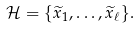Convert formula to latex. <formula><loc_0><loc_0><loc_500><loc_500>\mathcal { H } = \{ \widetilde { x } _ { 1 } , \dots , \widetilde { x } _ { \ell } \} .</formula> 